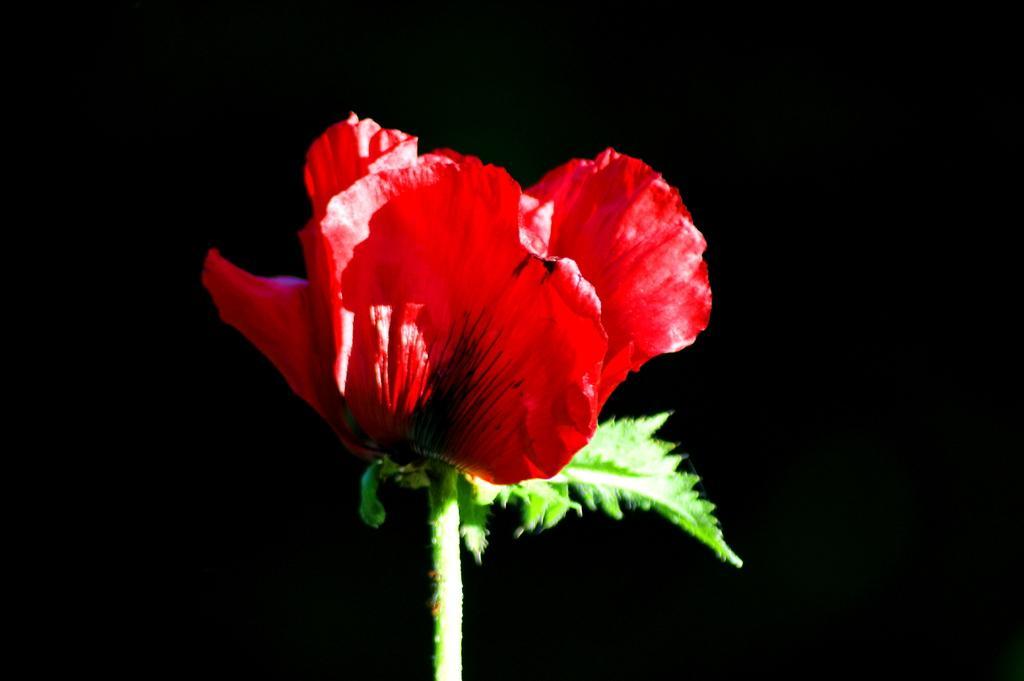In one or two sentences, can you explain what this image depicts? In this image in the foreground there is one flower, and in the background there is black color. 